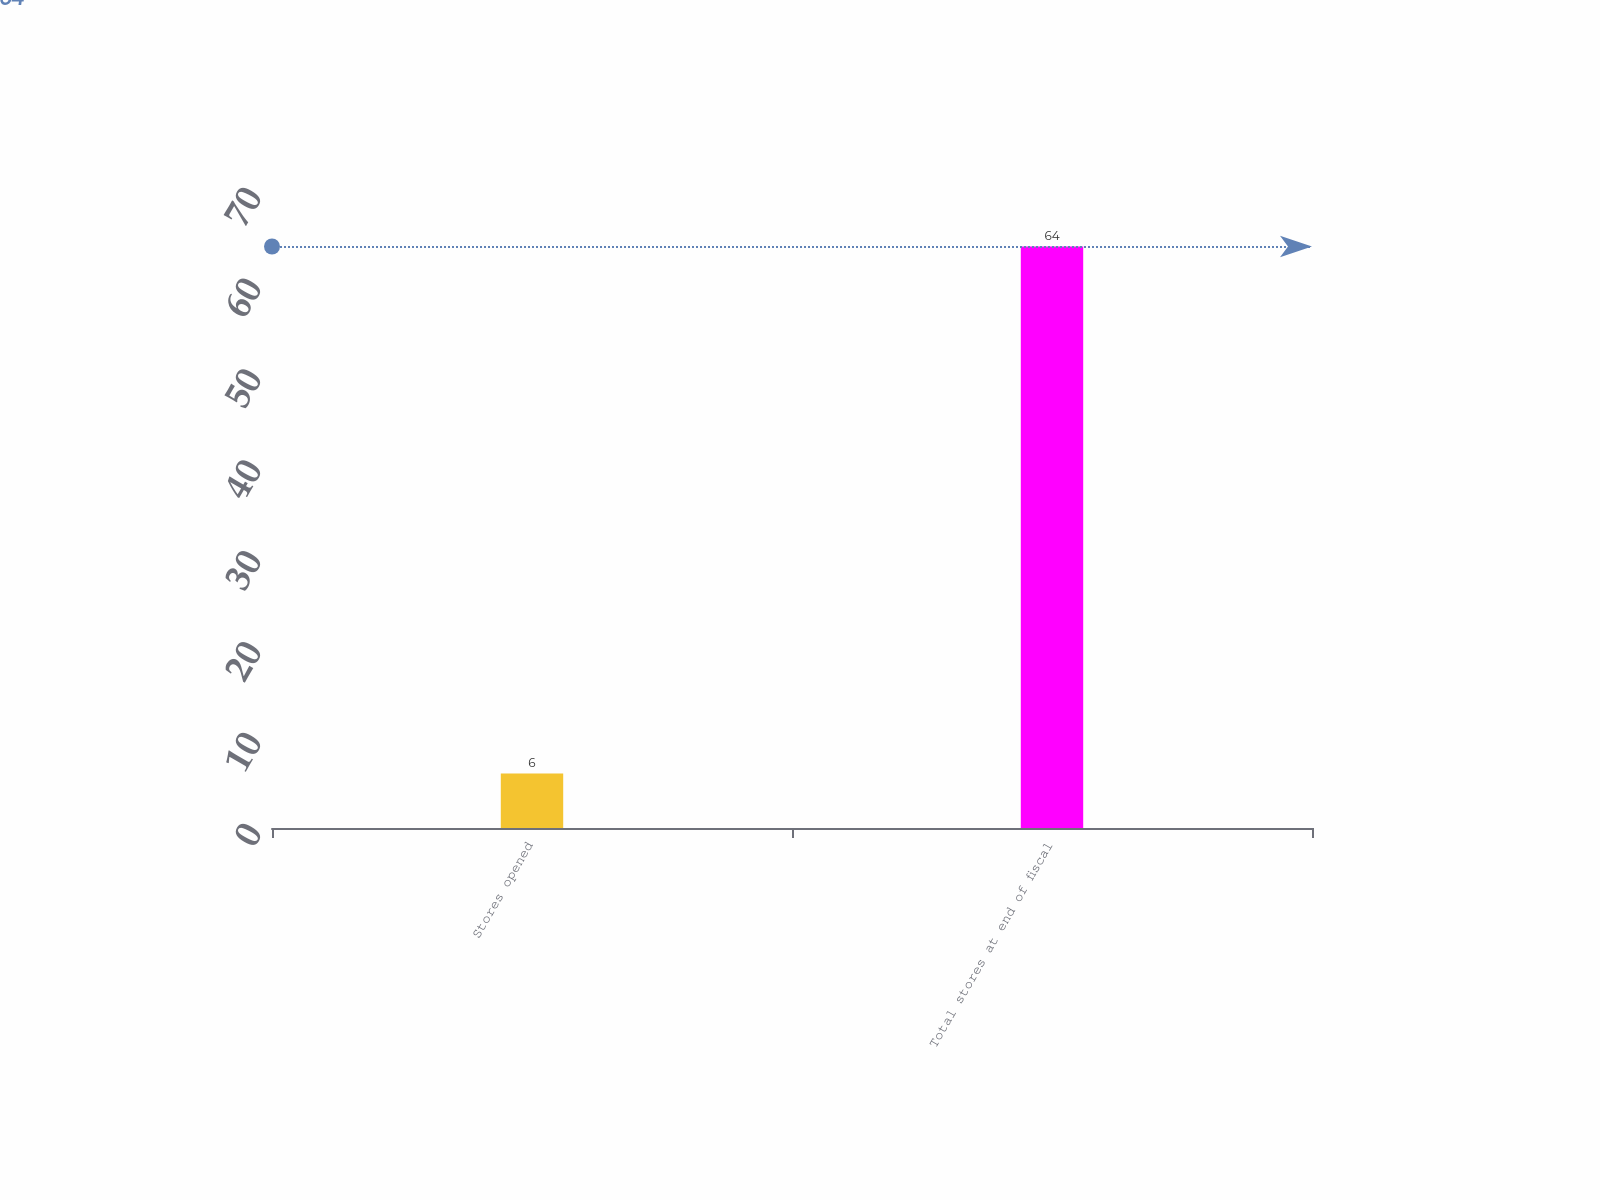Convert chart. <chart><loc_0><loc_0><loc_500><loc_500><bar_chart><fcel>Stores opened<fcel>Total stores at end of fiscal<nl><fcel>6<fcel>64<nl></chart> 